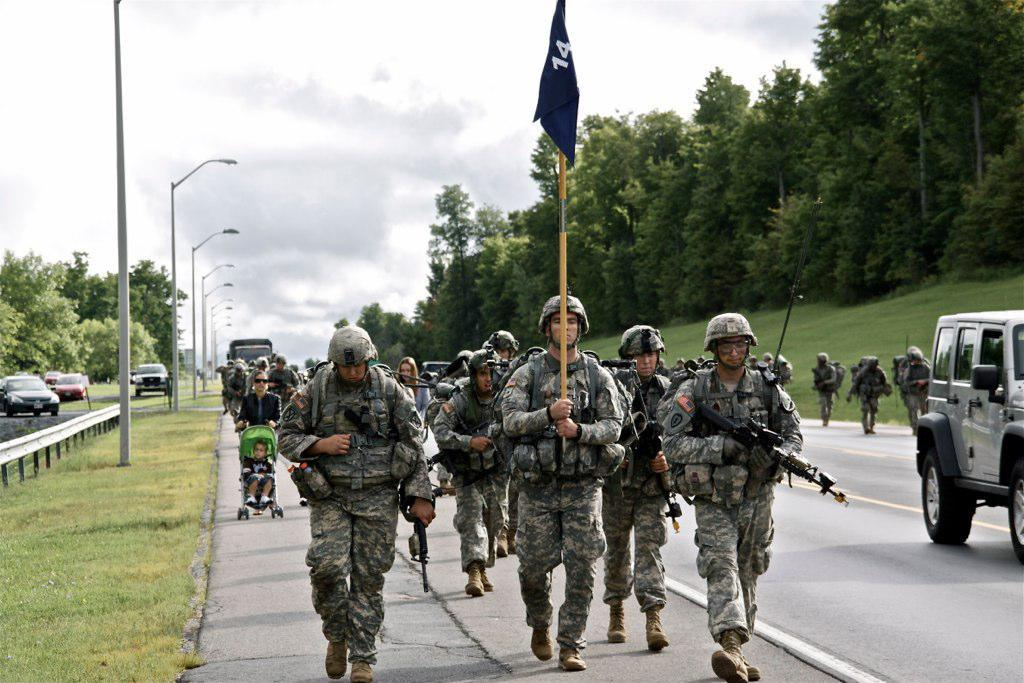What is happening on the road in the image? There are army men walking on the road in the image. What can be seen on the left side of the image? There are cars and street lamps on the left side of the image. What type of vegetation is present on either side of the image? There are trees on either side of the image. What is visible at the top of the image? The sky is visible at the top of the image. What type of cherry is being used to decorate the prison in the image? There is no cherry or prison present in the image. What type of destruction can be seen in the image? There is no destruction present in the image; it shows army men walking on the road, cars, street lamps, trees, and the sky. 